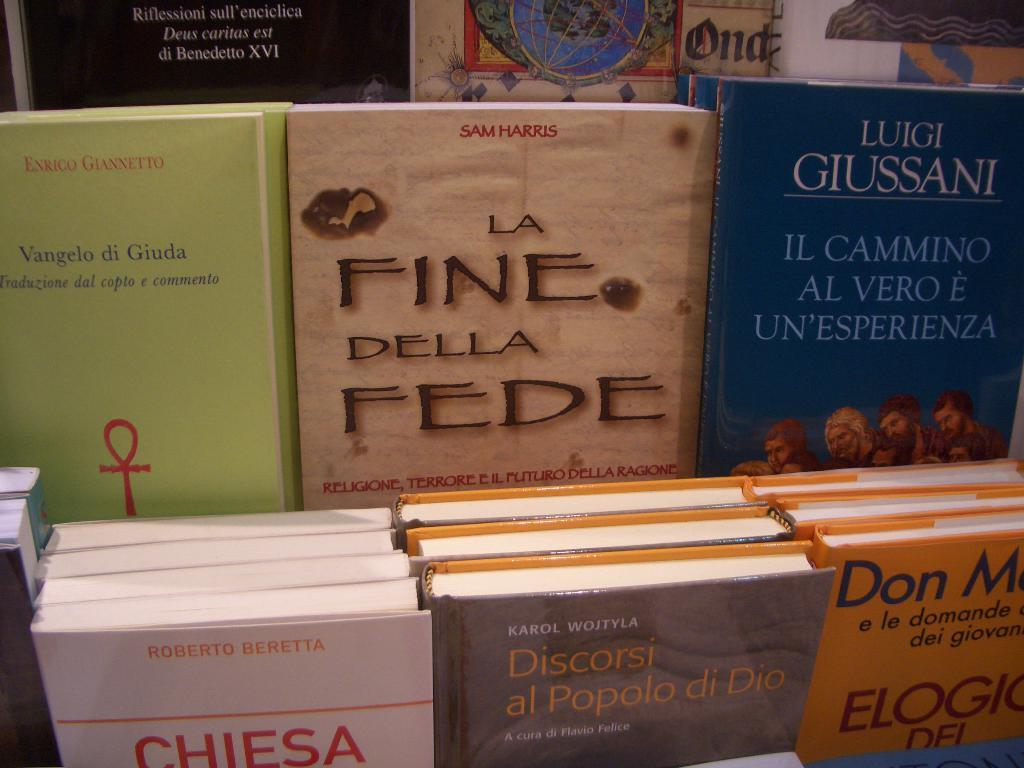<image>
Relay a brief, clear account of the picture shown. Various books with colorful colors are standing in a displace, the one in the center is La Fine Della Fede. 